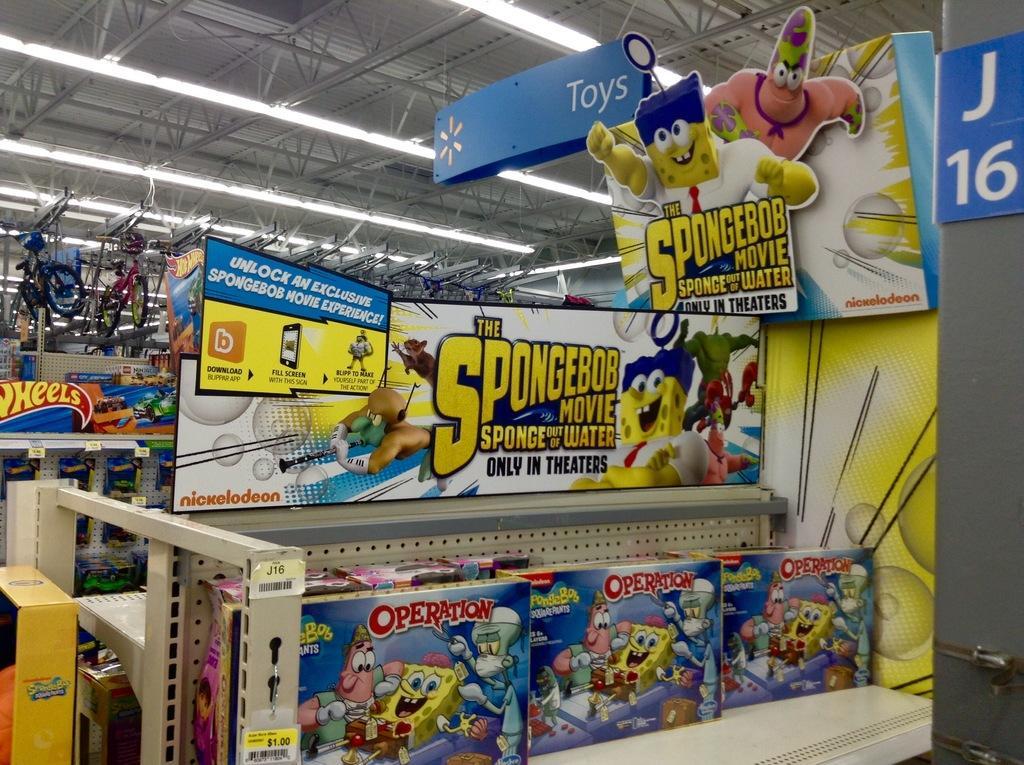Could you give a brief overview of what you see in this image? In this image I can see many colorful boxes on the rack. I can see many boards. In the background I can see few more boxes and many bicycles hanged. I can see the lights and the board at the top. 